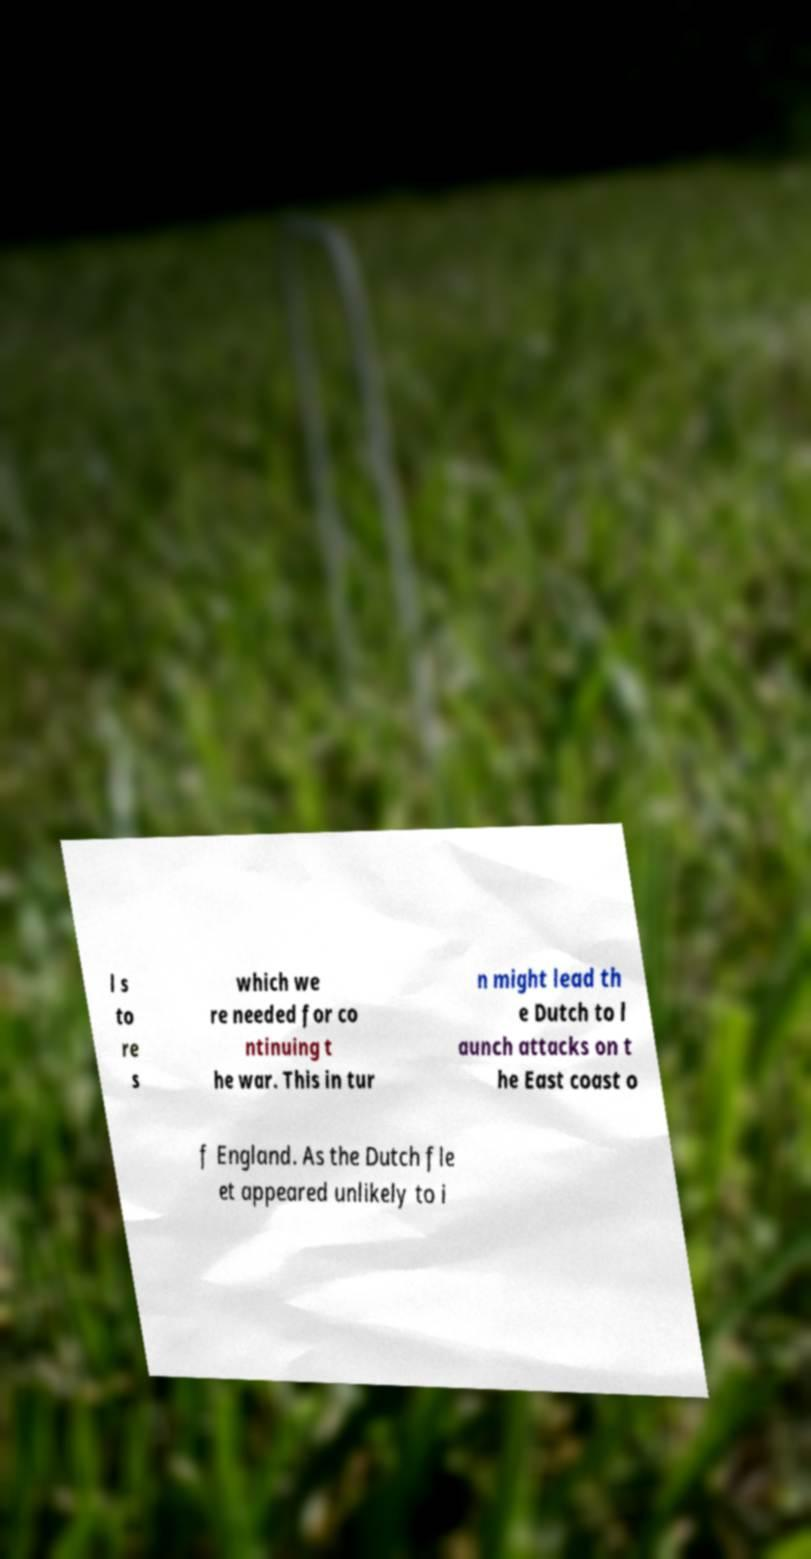Could you extract and type out the text from this image? l s to re s which we re needed for co ntinuing t he war. This in tur n might lead th e Dutch to l aunch attacks on t he East coast o f England. As the Dutch fle et appeared unlikely to i 